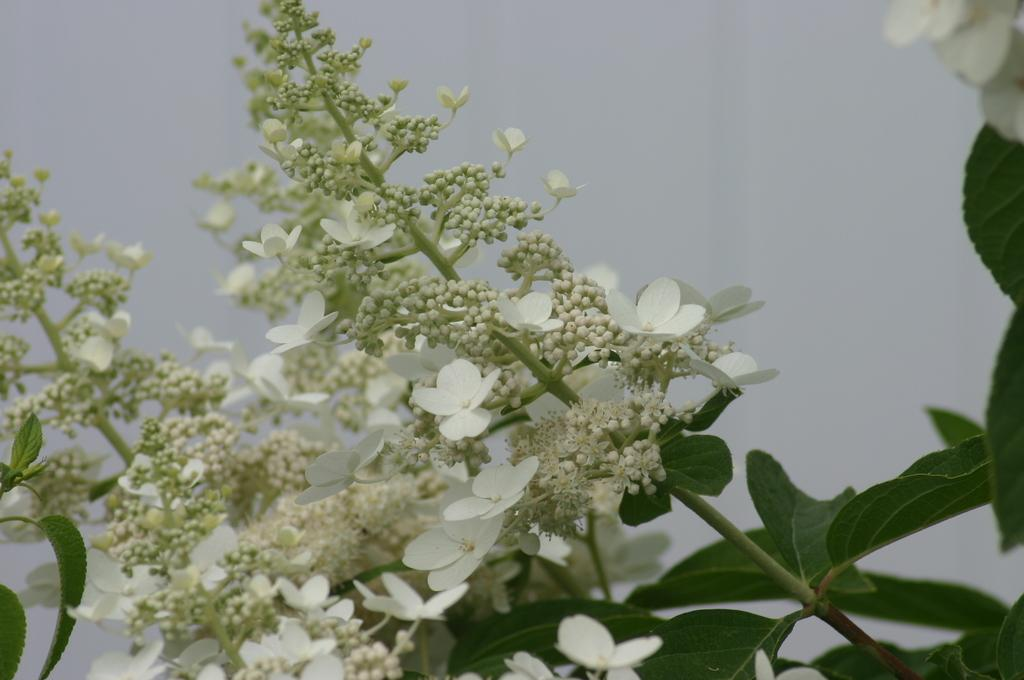What is located in the center of the image? There are plants, fruits, and flowers in the center of the image. What color are the plants, fruits, and flowers in the image? The plants, fruits, and flowers are in white color. What can be seen in the background of the image? There is a wall in the background of the image. How much wealth is depicted in the image? There is no depiction of wealth in the image; it features white plants, fruits, and flowers in the center and a wall in the background. 